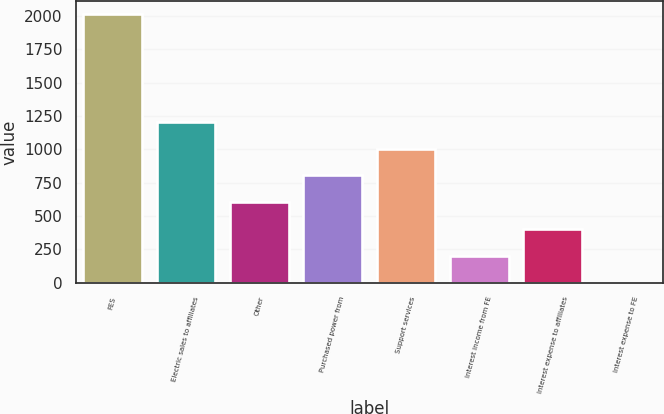Convert chart to OTSL. <chart><loc_0><loc_0><loc_500><loc_500><bar_chart><fcel>FES<fcel>Electric sales to affiliates<fcel>Other<fcel>Purchased power from<fcel>Support services<fcel>Interest income from FE<fcel>Interest expense to affiliates<fcel>Interest expense to FE<nl><fcel>2011<fcel>1207<fcel>604<fcel>805<fcel>1006<fcel>202<fcel>403<fcel>1<nl></chart> 